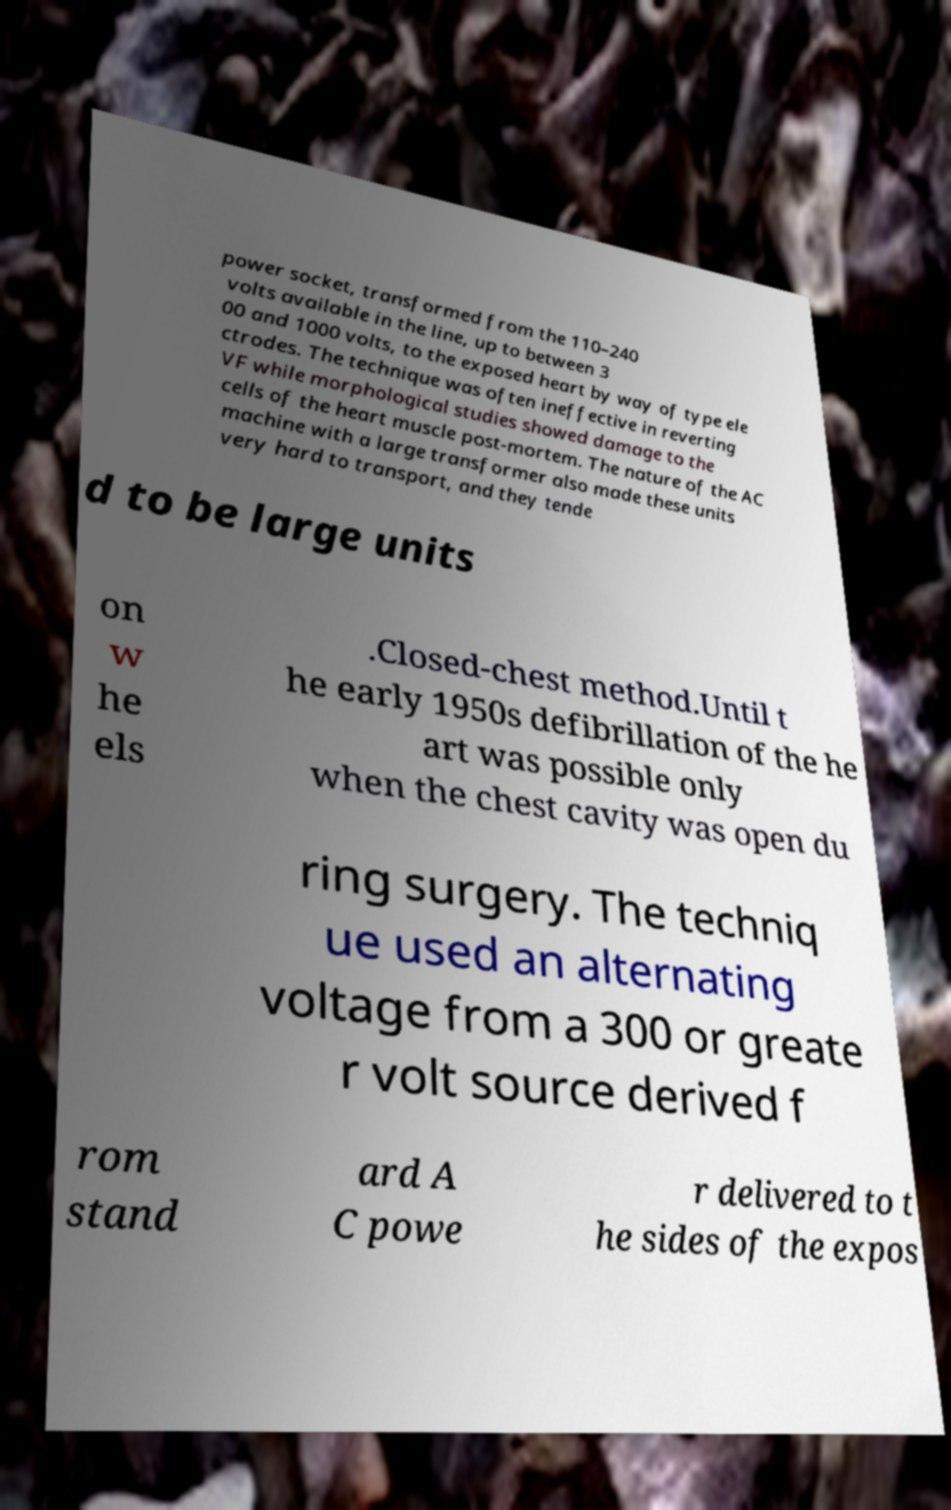Could you extract and type out the text from this image? power socket, transformed from the 110–240 volts available in the line, up to between 3 00 and 1000 volts, to the exposed heart by way of type ele ctrodes. The technique was often ineffective in reverting VF while morphological studies showed damage to the cells of the heart muscle post-mortem. The nature of the AC machine with a large transformer also made these units very hard to transport, and they tende d to be large units on w he els .Closed-chest method.Until t he early 1950s defibrillation of the he art was possible only when the chest cavity was open du ring surgery. The techniq ue used an alternating voltage from a 300 or greate r volt source derived f rom stand ard A C powe r delivered to t he sides of the expos 